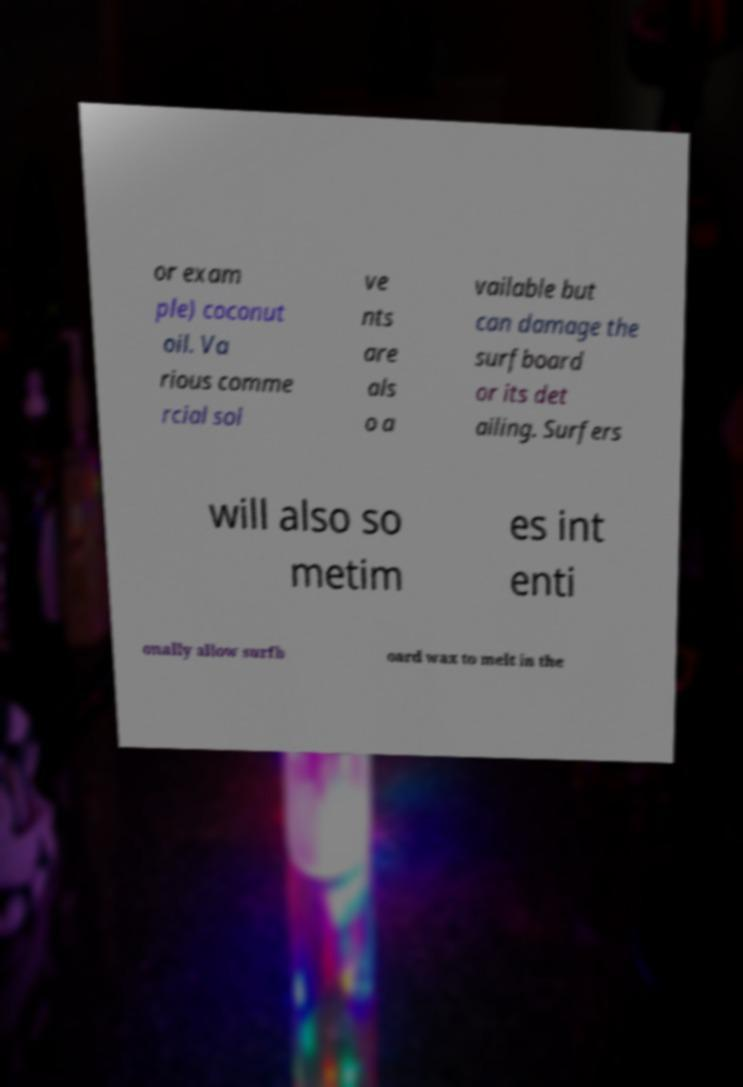Please read and relay the text visible in this image. What does it say? or exam ple) coconut oil. Va rious comme rcial sol ve nts are als o a vailable but can damage the surfboard or its det ailing. Surfers will also so metim es int enti onally allow surfb oard wax to melt in the 